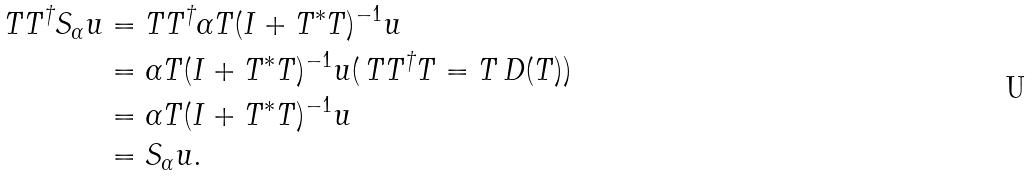<formula> <loc_0><loc_0><loc_500><loc_500>T T ^ { \dagger } S _ { \alpha } u & = T T ^ { \dagger } \alpha T ( I + T ^ { * } T ) ^ { - 1 } u \\ & = \alpha T ( I + T ^ { * } T ) ^ { - 1 } u ( \, T T ^ { \dagger } T = T \, D ( T ) ) \\ & = \alpha T ( I + T ^ { * } T ) ^ { - 1 } u \\ & = S _ { \alpha } u .</formula> 